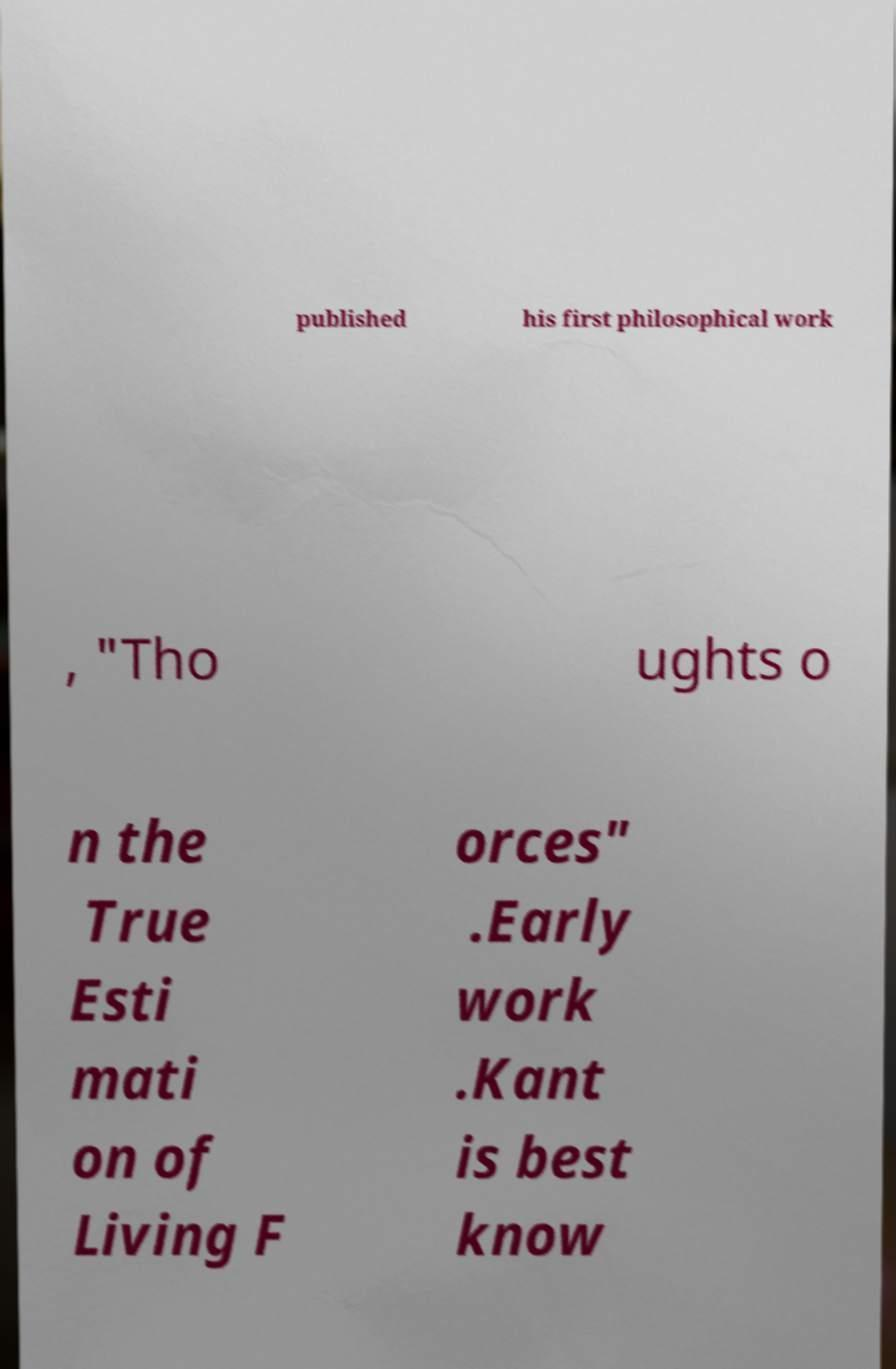Please read and relay the text visible in this image. What does it say? published his first philosophical work , "Tho ughts o n the True Esti mati on of Living F orces" .Early work .Kant is best know 